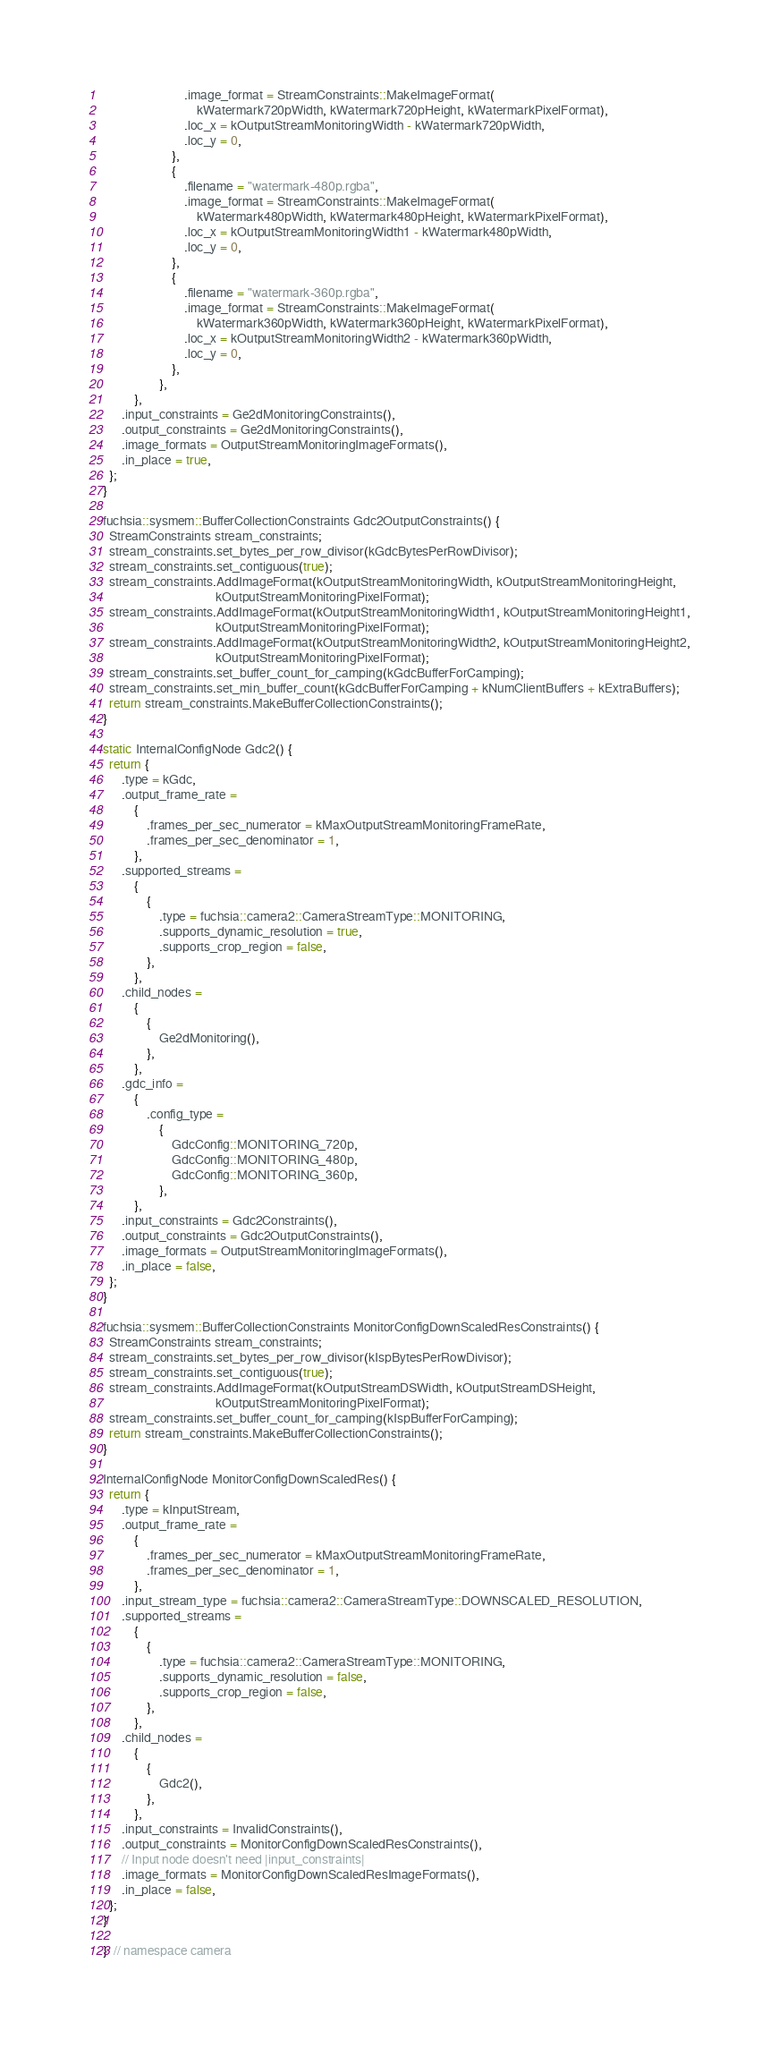Convert code to text. <code><loc_0><loc_0><loc_500><loc_500><_C++_>                          .image_format = StreamConstraints::MakeImageFormat(
                              kWatermark720pWidth, kWatermark720pHeight, kWatermarkPixelFormat),
                          .loc_x = kOutputStreamMonitoringWidth - kWatermark720pWidth,
                          .loc_y = 0,
                      },
                      {
                          .filename = "watermark-480p.rgba",
                          .image_format = StreamConstraints::MakeImageFormat(
                              kWatermark480pWidth, kWatermark480pHeight, kWatermarkPixelFormat),
                          .loc_x = kOutputStreamMonitoringWidth1 - kWatermark480pWidth,
                          .loc_y = 0,
                      },
                      {
                          .filename = "watermark-360p.rgba",
                          .image_format = StreamConstraints::MakeImageFormat(
                              kWatermark360pWidth, kWatermark360pHeight, kWatermarkPixelFormat),
                          .loc_x = kOutputStreamMonitoringWidth2 - kWatermark360pWidth,
                          .loc_y = 0,
                      },
                  },
          },
      .input_constraints = Ge2dMonitoringConstraints(),
      .output_constraints = Ge2dMonitoringConstraints(),
      .image_formats = OutputStreamMonitoringImageFormats(),
      .in_place = true,
  };
}

fuchsia::sysmem::BufferCollectionConstraints Gdc2OutputConstraints() {
  StreamConstraints stream_constraints;
  stream_constraints.set_bytes_per_row_divisor(kGdcBytesPerRowDivisor);
  stream_constraints.set_contiguous(true);
  stream_constraints.AddImageFormat(kOutputStreamMonitoringWidth, kOutputStreamMonitoringHeight,
                                    kOutputStreamMonitoringPixelFormat);
  stream_constraints.AddImageFormat(kOutputStreamMonitoringWidth1, kOutputStreamMonitoringHeight1,
                                    kOutputStreamMonitoringPixelFormat);
  stream_constraints.AddImageFormat(kOutputStreamMonitoringWidth2, kOutputStreamMonitoringHeight2,
                                    kOutputStreamMonitoringPixelFormat);
  stream_constraints.set_buffer_count_for_camping(kGdcBufferForCamping);
  stream_constraints.set_min_buffer_count(kGdcBufferForCamping + kNumClientBuffers + kExtraBuffers);
  return stream_constraints.MakeBufferCollectionConstraints();
}

static InternalConfigNode Gdc2() {
  return {
      .type = kGdc,
      .output_frame_rate =
          {
              .frames_per_sec_numerator = kMaxOutputStreamMonitoringFrameRate,
              .frames_per_sec_denominator = 1,
          },
      .supported_streams =
          {
              {
                  .type = fuchsia::camera2::CameraStreamType::MONITORING,
                  .supports_dynamic_resolution = true,
                  .supports_crop_region = false,
              },
          },
      .child_nodes =
          {
              {
                  Ge2dMonitoring(),
              },
          },
      .gdc_info =
          {
              .config_type =
                  {
                      GdcConfig::MONITORING_720p,
                      GdcConfig::MONITORING_480p,
                      GdcConfig::MONITORING_360p,
                  },
          },
      .input_constraints = Gdc2Constraints(),
      .output_constraints = Gdc2OutputConstraints(),
      .image_formats = OutputStreamMonitoringImageFormats(),
      .in_place = false,
  };
}

fuchsia::sysmem::BufferCollectionConstraints MonitorConfigDownScaledResConstraints() {
  StreamConstraints stream_constraints;
  stream_constraints.set_bytes_per_row_divisor(kIspBytesPerRowDivisor);
  stream_constraints.set_contiguous(true);
  stream_constraints.AddImageFormat(kOutputStreamDSWidth, kOutputStreamDSHeight,
                                    kOutputStreamMonitoringPixelFormat);
  stream_constraints.set_buffer_count_for_camping(kIspBufferForCamping);
  return stream_constraints.MakeBufferCollectionConstraints();
}

InternalConfigNode MonitorConfigDownScaledRes() {
  return {
      .type = kInputStream,
      .output_frame_rate =
          {
              .frames_per_sec_numerator = kMaxOutputStreamMonitoringFrameRate,
              .frames_per_sec_denominator = 1,
          },
      .input_stream_type = fuchsia::camera2::CameraStreamType::DOWNSCALED_RESOLUTION,
      .supported_streams =
          {
              {
                  .type = fuchsia::camera2::CameraStreamType::MONITORING,
                  .supports_dynamic_resolution = false,
                  .supports_crop_region = false,
              },
          },
      .child_nodes =
          {
              {
                  Gdc2(),
              },
          },
      .input_constraints = InvalidConstraints(),
      .output_constraints = MonitorConfigDownScaledResConstraints(),
      // Input node doesn't need |input_constraints|
      .image_formats = MonitorConfigDownScaledResImageFormats(),
      .in_place = false,
  };
}

}  // namespace camera
</code> 